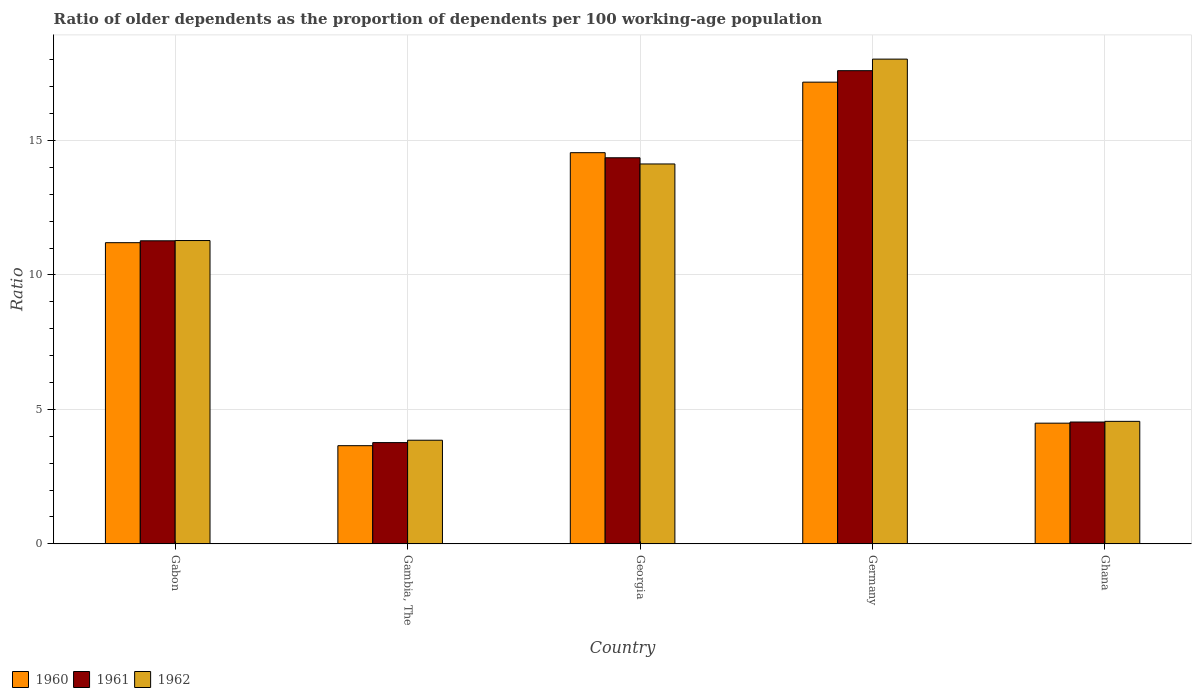How many groups of bars are there?
Make the answer very short. 5. Are the number of bars per tick equal to the number of legend labels?
Your response must be concise. Yes. How many bars are there on the 4th tick from the left?
Provide a short and direct response. 3. What is the label of the 3rd group of bars from the left?
Offer a very short reply. Georgia. In how many cases, is the number of bars for a given country not equal to the number of legend labels?
Ensure brevity in your answer.  0. What is the age dependency ratio(old) in 1962 in Ghana?
Offer a terse response. 4.56. Across all countries, what is the maximum age dependency ratio(old) in 1960?
Keep it short and to the point. 17.17. Across all countries, what is the minimum age dependency ratio(old) in 1961?
Your answer should be compact. 3.77. In which country was the age dependency ratio(old) in 1961 maximum?
Your response must be concise. Germany. In which country was the age dependency ratio(old) in 1962 minimum?
Your answer should be very brief. Gambia, The. What is the total age dependency ratio(old) in 1960 in the graph?
Provide a succinct answer. 51.05. What is the difference between the age dependency ratio(old) in 1961 in Gabon and that in Ghana?
Offer a terse response. 6.74. What is the difference between the age dependency ratio(old) in 1961 in Gambia, The and the age dependency ratio(old) in 1962 in Germany?
Provide a succinct answer. -14.26. What is the average age dependency ratio(old) in 1960 per country?
Provide a succinct answer. 10.21. What is the difference between the age dependency ratio(old) of/in 1960 and age dependency ratio(old) of/in 1961 in Georgia?
Make the answer very short. 0.19. In how many countries, is the age dependency ratio(old) in 1961 greater than 14?
Provide a short and direct response. 2. What is the ratio of the age dependency ratio(old) in 1961 in Georgia to that in Ghana?
Provide a succinct answer. 3.17. Is the difference between the age dependency ratio(old) in 1960 in Gambia, The and Ghana greater than the difference between the age dependency ratio(old) in 1961 in Gambia, The and Ghana?
Provide a succinct answer. No. What is the difference between the highest and the second highest age dependency ratio(old) in 1961?
Provide a short and direct response. 6.33. What is the difference between the highest and the lowest age dependency ratio(old) in 1960?
Your answer should be compact. 13.52. Is the sum of the age dependency ratio(old) in 1962 in Gabon and Georgia greater than the maximum age dependency ratio(old) in 1960 across all countries?
Provide a succinct answer. Yes. What does the 1st bar from the left in Gambia, The represents?
Keep it short and to the point. 1960. What does the 2nd bar from the right in Ghana represents?
Keep it short and to the point. 1961. Are all the bars in the graph horizontal?
Your answer should be compact. No. How many countries are there in the graph?
Your answer should be compact. 5. What is the difference between two consecutive major ticks on the Y-axis?
Offer a very short reply. 5. Are the values on the major ticks of Y-axis written in scientific E-notation?
Provide a succinct answer. No. Does the graph contain any zero values?
Your answer should be very brief. No. Where does the legend appear in the graph?
Your answer should be compact. Bottom left. What is the title of the graph?
Offer a terse response. Ratio of older dependents as the proportion of dependents per 100 working-age population. Does "1990" appear as one of the legend labels in the graph?
Your response must be concise. No. What is the label or title of the Y-axis?
Make the answer very short. Ratio. What is the Ratio in 1960 in Gabon?
Your answer should be compact. 11.2. What is the Ratio of 1961 in Gabon?
Provide a short and direct response. 11.27. What is the Ratio in 1962 in Gabon?
Offer a very short reply. 11.28. What is the Ratio in 1960 in Gambia, The?
Offer a terse response. 3.65. What is the Ratio in 1961 in Gambia, The?
Your answer should be very brief. 3.77. What is the Ratio of 1962 in Gambia, The?
Your response must be concise. 3.85. What is the Ratio of 1960 in Georgia?
Your answer should be compact. 14.55. What is the Ratio of 1961 in Georgia?
Give a very brief answer. 14.36. What is the Ratio in 1962 in Georgia?
Your response must be concise. 14.13. What is the Ratio of 1960 in Germany?
Make the answer very short. 17.17. What is the Ratio of 1961 in Germany?
Provide a succinct answer. 17.59. What is the Ratio of 1962 in Germany?
Your answer should be compact. 18.02. What is the Ratio of 1960 in Ghana?
Give a very brief answer. 4.49. What is the Ratio in 1961 in Ghana?
Your answer should be very brief. 4.53. What is the Ratio in 1962 in Ghana?
Ensure brevity in your answer.  4.56. Across all countries, what is the maximum Ratio of 1960?
Provide a succinct answer. 17.17. Across all countries, what is the maximum Ratio of 1961?
Your response must be concise. 17.59. Across all countries, what is the maximum Ratio in 1962?
Offer a very short reply. 18.02. Across all countries, what is the minimum Ratio in 1960?
Provide a succinct answer. 3.65. Across all countries, what is the minimum Ratio of 1961?
Make the answer very short. 3.77. Across all countries, what is the minimum Ratio of 1962?
Keep it short and to the point. 3.85. What is the total Ratio of 1960 in the graph?
Make the answer very short. 51.05. What is the total Ratio of 1961 in the graph?
Offer a terse response. 51.51. What is the total Ratio of 1962 in the graph?
Offer a terse response. 51.84. What is the difference between the Ratio of 1960 in Gabon and that in Gambia, The?
Your answer should be compact. 7.55. What is the difference between the Ratio in 1961 in Gabon and that in Gambia, The?
Ensure brevity in your answer.  7.5. What is the difference between the Ratio in 1962 in Gabon and that in Gambia, The?
Offer a very short reply. 7.42. What is the difference between the Ratio of 1960 in Gabon and that in Georgia?
Your answer should be very brief. -3.35. What is the difference between the Ratio in 1961 in Gabon and that in Georgia?
Your answer should be very brief. -3.09. What is the difference between the Ratio in 1962 in Gabon and that in Georgia?
Provide a short and direct response. -2.85. What is the difference between the Ratio of 1960 in Gabon and that in Germany?
Your response must be concise. -5.97. What is the difference between the Ratio of 1961 in Gabon and that in Germany?
Make the answer very short. -6.33. What is the difference between the Ratio in 1962 in Gabon and that in Germany?
Keep it short and to the point. -6.75. What is the difference between the Ratio in 1960 in Gabon and that in Ghana?
Give a very brief answer. 6.71. What is the difference between the Ratio in 1961 in Gabon and that in Ghana?
Keep it short and to the point. 6.74. What is the difference between the Ratio in 1962 in Gabon and that in Ghana?
Offer a very short reply. 6.72. What is the difference between the Ratio in 1960 in Gambia, The and that in Georgia?
Your answer should be compact. -10.9. What is the difference between the Ratio of 1961 in Gambia, The and that in Georgia?
Provide a succinct answer. -10.59. What is the difference between the Ratio of 1962 in Gambia, The and that in Georgia?
Offer a terse response. -10.27. What is the difference between the Ratio of 1960 in Gambia, The and that in Germany?
Your answer should be very brief. -13.52. What is the difference between the Ratio in 1961 in Gambia, The and that in Germany?
Keep it short and to the point. -13.83. What is the difference between the Ratio of 1962 in Gambia, The and that in Germany?
Ensure brevity in your answer.  -14.17. What is the difference between the Ratio of 1960 in Gambia, The and that in Ghana?
Provide a succinct answer. -0.84. What is the difference between the Ratio in 1961 in Gambia, The and that in Ghana?
Your answer should be very brief. -0.77. What is the difference between the Ratio of 1962 in Gambia, The and that in Ghana?
Your answer should be very brief. -0.7. What is the difference between the Ratio in 1960 in Georgia and that in Germany?
Keep it short and to the point. -2.62. What is the difference between the Ratio in 1961 in Georgia and that in Germany?
Ensure brevity in your answer.  -3.24. What is the difference between the Ratio of 1962 in Georgia and that in Germany?
Offer a terse response. -3.9. What is the difference between the Ratio in 1960 in Georgia and that in Ghana?
Offer a very short reply. 10.06. What is the difference between the Ratio in 1961 in Georgia and that in Ghana?
Give a very brief answer. 9.83. What is the difference between the Ratio of 1962 in Georgia and that in Ghana?
Provide a succinct answer. 9.57. What is the difference between the Ratio of 1960 in Germany and that in Ghana?
Offer a very short reply. 12.68. What is the difference between the Ratio in 1961 in Germany and that in Ghana?
Ensure brevity in your answer.  13.06. What is the difference between the Ratio of 1962 in Germany and that in Ghana?
Keep it short and to the point. 13.47. What is the difference between the Ratio in 1960 in Gabon and the Ratio in 1961 in Gambia, The?
Your answer should be very brief. 7.43. What is the difference between the Ratio of 1960 in Gabon and the Ratio of 1962 in Gambia, The?
Keep it short and to the point. 7.35. What is the difference between the Ratio of 1961 in Gabon and the Ratio of 1962 in Gambia, The?
Your response must be concise. 7.42. What is the difference between the Ratio in 1960 in Gabon and the Ratio in 1961 in Georgia?
Provide a succinct answer. -3.16. What is the difference between the Ratio in 1960 in Gabon and the Ratio in 1962 in Georgia?
Your answer should be compact. -2.93. What is the difference between the Ratio of 1961 in Gabon and the Ratio of 1962 in Georgia?
Ensure brevity in your answer.  -2.86. What is the difference between the Ratio of 1960 in Gabon and the Ratio of 1961 in Germany?
Offer a terse response. -6.4. What is the difference between the Ratio in 1960 in Gabon and the Ratio in 1962 in Germany?
Offer a terse response. -6.83. What is the difference between the Ratio of 1961 in Gabon and the Ratio of 1962 in Germany?
Offer a terse response. -6.76. What is the difference between the Ratio in 1960 in Gabon and the Ratio in 1961 in Ghana?
Provide a short and direct response. 6.67. What is the difference between the Ratio of 1960 in Gabon and the Ratio of 1962 in Ghana?
Your response must be concise. 6.64. What is the difference between the Ratio of 1961 in Gabon and the Ratio of 1962 in Ghana?
Provide a short and direct response. 6.71. What is the difference between the Ratio of 1960 in Gambia, The and the Ratio of 1961 in Georgia?
Provide a succinct answer. -10.71. What is the difference between the Ratio of 1960 in Gambia, The and the Ratio of 1962 in Georgia?
Your answer should be very brief. -10.48. What is the difference between the Ratio of 1961 in Gambia, The and the Ratio of 1962 in Georgia?
Make the answer very short. -10.36. What is the difference between the Ratio of 1960 in Gambia, The and the Ratio of 1961 in Germany?
Ensure brevity in your answer.  -13.94. What is the difference between the Ratio in 1960 in Gambia, The and the Ratio in 1962 in Germany?
Make the answer very short. -14.37. What is the difference between the Ratio of 1961 in Gambia, The and the Ratio of 1962 in Germany?
Give a very brief answer. -14.26. What is the difference between the Ratio of 1960 in Gambia, The and the Ratio of 1961 in Ghana?
Give a very brief answer. -0.88. What is the difference between the Ratio of 1960 in Gambia, The and the Ratio of 1962 in Ghana?
Your answer should be compact. -0.9. What is the difference between the Ratio in 1961 in Gambia, The and the Ratio in 1962 in Ghana?
Give a very brief answer. -0.79. What is the difference between the Ratio in 1960 in Georgia and the Ratio in 1961 in Germany?
Your answer should be very brief. -3.05. What is the difference between the Ratio of 1960 in Georgia and the Ratio of 1962 in Germany?
Provide a short and direct response. -3.48. What is the difference between the Ratio in 1961 in Georgia and the Ratio in 1962 in Germany?
Provide a short and direct response. -3.67. What is the difference between the Ratio in 1960 in Georgia and the Ratio in 1961 in Ghana?
Give a very brief answer. 10.02. What is the difference between the Ratio in 1960 in Georgia and the Ratio in 1962 in Ghana?
Your answer should be compact. 9.99. What is the difference between the Ratio of 1961 in Georgia and the Ratio of 1962 in Ghana?
Your answer should be compact. 9.8. What is the difference between the Ratio of 1960 in Germany and the Ratio of 1961 in Ghana?
Your answer should be compact. 12.64. What is the difference between the Ratio of 1960 in Germany and the Ratio of 1962 in Ghana?
Make the answer very short. 12.61. What is the difference between the Ratio of 1961 in Germany and the Ratio of 1962 in Ghana?
Your answer should be compact. 13.04. What is the average Ratio in 1960 per country?
Keep it short and to the point. 10.21. What is the average Ratio in 1961 per country?
Give a very brief answer. 10.3. What is the average Ratio in 1962 per country?
Keep it short and to the point. 10.37. What is the difference between the Ratio of 1960 and Ratio of 1961 in Gabon?
Offer a terse response. -0.07. What is the difference between the Ratio in 1960 and Ratio in 1962 in Gabon?
Offer a terse response. -0.08. What is the difference between the Ratio of 1961 and Ratio of 1962 in Gabon?
Ensure brevity in your answer.  -0.01. What is the difference between the Ratio of 1960 and Ratio of 1961 in Gambia, The?
Provide a short and direct response. -0.11. What is the difference between the Ratio of 1960 and Ratio of 1962 in Gambia, The?
Make the answer very short. -0.2. What is the difference between the Ratio of 1961 and Ratio of 1962 in Gambia, The?
Ensure brevity in your answer.  -0.09. What is the difference between the Ratio of 1960 and Ratio of 1961 in Georgia?
Offer a very short reply. 0.19. What is the difference between the Ratio in 1960 and Ratio in 1962 in Georgia?
Give a very brief answer. 0.42. What is the difference between the Ratio in 1961 and Ratio in 1962 in Georgia?
Offer a very short reply. 0.23. What is the difference between the Ratio of 1960 and Ratio of 1961 in Germany?
Your response must be concise. -0.43. What is the difference between the Ratio in 1960 and Ratio in 1962 in Germany?
Your answer should be compact. -0.86. What is the difference between the Ratio of 1961 and Ratio of 1962 in Germany?
Keep it short and to the point. -0.43. What is the difference between the Ratio in 1960 and Ratio in 1961 in Ghana?
Make the answer very short. -0.04. What is the difference between the Ratio of 1960 and Ratio of 1962 in Ghana?
Offer a very short reply. -0.07. What is the difference between the Ratio in 1961 and Ratio in 1962 in Ghana?
Make the answer very short. -0.02. What is the ratio of the Ratio of 1960 in Gabon to that in Gambia, The?
Make the answer very short. 3.07. What is the ratio of the Ratio in 1961 in Gabon to that in Gambia, The?
Offer a very short reply. 2.99. What is the ratio of the Ratio of 1962 in Gabon to that in Gambia, The?
Provide a short and direct response. 2.93. What is the ratio of the Ratio of 1960 in Gabon to that in Georgia?
Provide a succinct answer. 0.77. What is the ratio of the Ratio of 1961 in Gabon to that in Georgia?
Offer a very short reply. 0.78. What is the ratio of the Ratio of 1962 in Gabon to that in Georgia?
Your answer should be compact. 0.8. What is the ratio of the Ratio of 1960 in Gabon to that in Germany?
Offer a very short reply. 0.65. What is the ratio of the Ratio in 1961 in Gabon to that in Germany?
Provide a short and direct response. 0.64. What is the ratio of the Ratio in 1962 in Gabon to that in Germany?
Provide a succinct answer. 0.63. What is the ratio of the Ratio of 1960 in Gabon to that in Ghana?
Provide a short and direct response. 2.5. What is the ratio of the Ratio in 1961 in Gabon to that in Ghana?
Your answer should be very brief. 2.49. What is the ratio of the Ratio of 1962 in Gabon to that in Ghana?
Offer a very short reply. 2.48. What is the ratio of the Ratio in 1960 in Gambia, The to that in Georgia?
Keep it short and to the point. 0.25. What is the ratio of the Ratio of 1961 in Gambia, The to that in Georgia?
Your answer should be very brief. 0.26. What is the ratio of the Ratio in 1962 in Gambia, The to that in Georgia?
Offer a terse response. 0.27. What is the ratio of the Ratio of 1960 in Gambia, The to that in Germany?
Keep it short and to the point. 0.21. What is the ratio of the Ratio of 1961 in Gambia, The to that in Germany?
Provide a short and direct response. 0.21. What is the ratio of the Ratio of 1962 in Gambia, The to that in Germany?
Your answer should be compact. 0.21. What is the ratio of the Ratio in 1960 in Gambia, The to that in Ghana?
Your answer should be very brief. 0.81. What is the ratio of the Ratio in 1961 in Gambia, The to that in Ghana?
Your response must be concise. 0.83. What is the ratio of the Ratio in 1962 in Gambia, The to that in Ghana?
Offer a terse response. 0.85. What is the ratio of the Ratio of 1960 in Georgia to that in Germany?
Keep it short and to the point. 0.85. What is the ratio of the Ratio of 1961 in Georgia to that in Germany?
Make the answer very short. 0.82. What is the ratio of the Ratio of 1962 in Georgia to that in Germany?
Provide a short and direct response. 0.78. What is the ratio of the Ratio in 1960 in Georgia to that in Ghana?
Offer a terse response. 3.24. What is the ratio of the Ratio in 1961 in Georgia to that in Ghana?
Provide a succinct answer. 3.17. What is the ratio of the Ratio of 1962 in Georgia to that in Ghana?
Ensure brevity in your answer.  3.1. What is the ratio of the Ratio in 1960 in Germany to that in Ghana?
Keep it short and to the point. 3.83. What is the ratio of the Ratio in 1961 in Germany to that in Ghana?
Your answer should be compact. 3.88. What is the ratio of the Ratio in 1962 in Germany to that in Ghana?
Give a very brief answer. 3.96. What is the difference between the highest and the second highest Ratio in 1960?
Give a very brief answer. 2.62. What is the difference between the highest and the second highest Ratio in 1961?
Your answer should be very brief. 3.24. What is the difference between the highest and the second highest Ratio of 1962?
Offer a very short reply. 3.9. What is the difference between the highest and the lowest Ratio in 1960?
Offer a terse response. 13.52. What is the difference between the highest and the lowest Ratio in 1961?
Your answer should be very brief. 13.83. What is the difference between the highest and the lowest Ratio in 1962?
Your response must be concise. 14.17. 